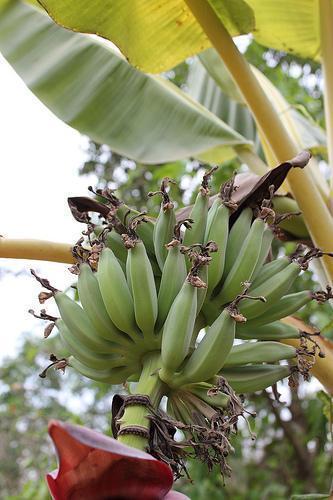How many kinds of fruits?
Give a very brief answer. 1. 